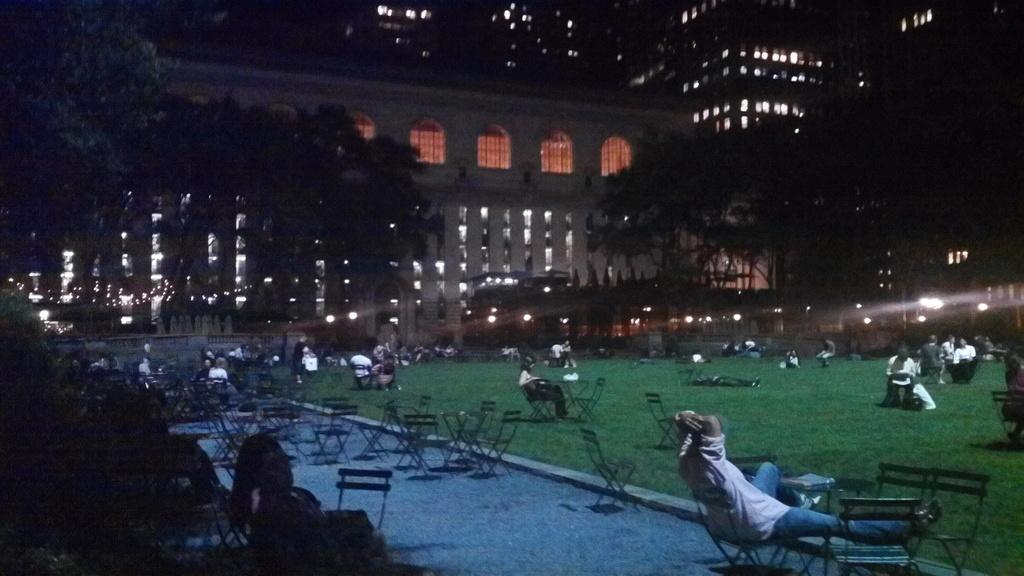How would you summarize this image in a sentence or two? This image is taken outdoors. At the bottom of the image there is a floor and there is a ground with grass on it. In the middle of the image there are many empty chairs and tables. Many people are sitting on the chairs and a few are standing on the ground. In the background there are a few buildings and there are a few trees and there are many lights. 